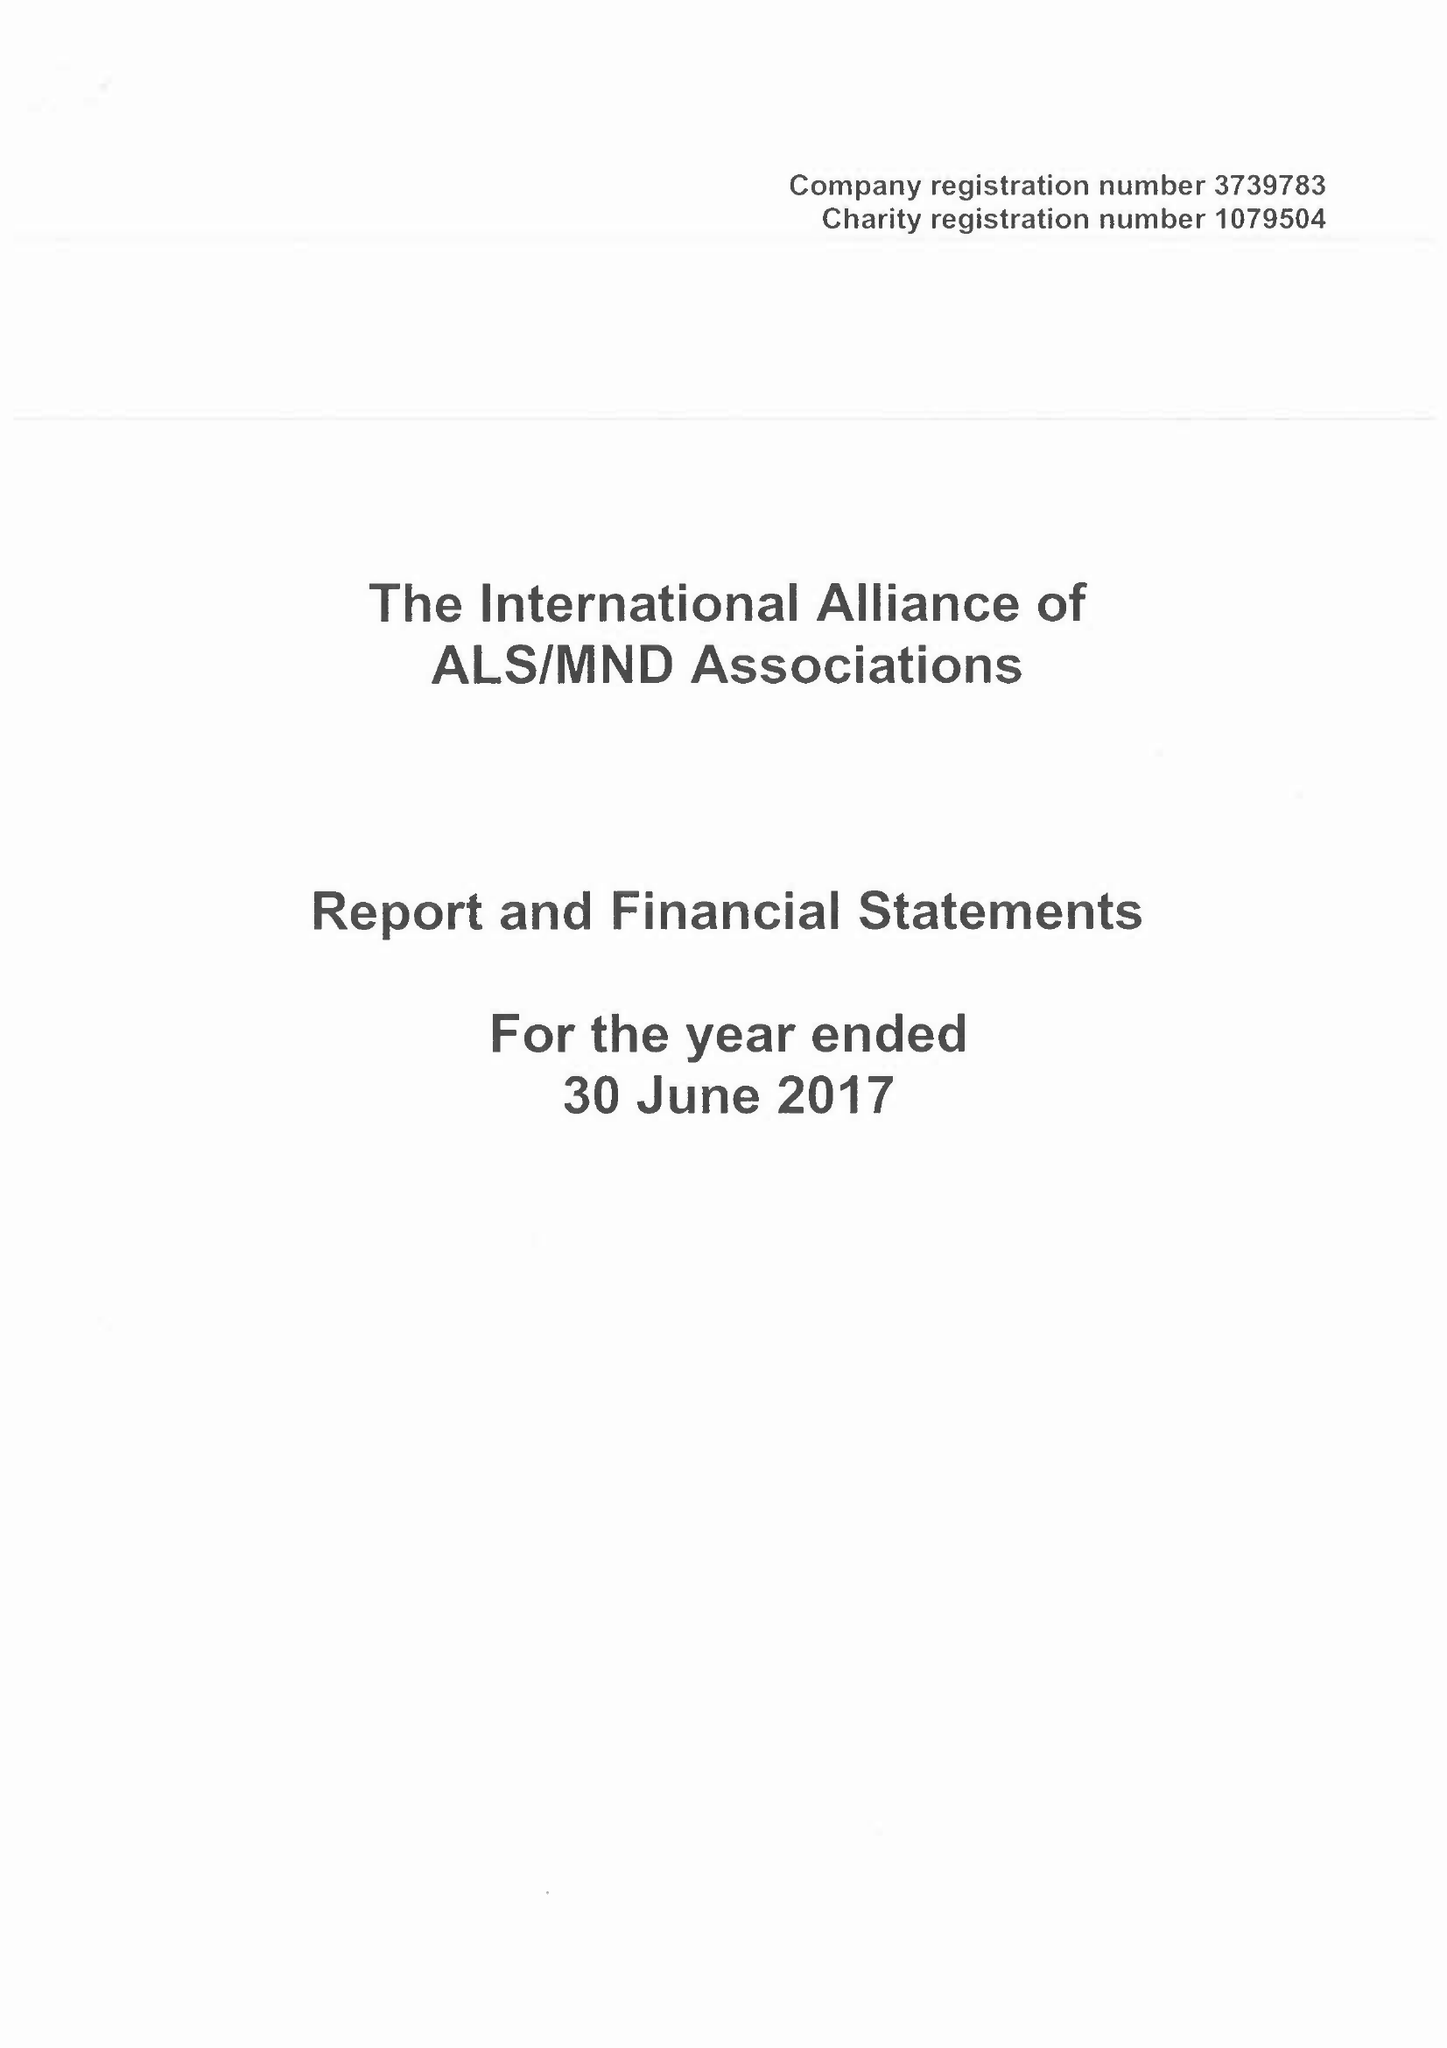What is the value for the income_annually_in_british_pounds?
Answer the question using a single word or phrase. 176527.00 